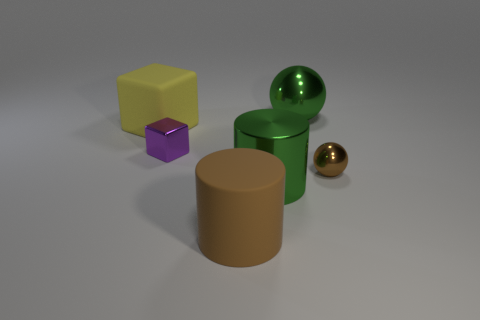Is there anything else that has the same shape as the brown matte object?
Your response must be concise. Yes. Are there more rubber things than small brown metal objects?
Your answer should be very brief. Yes. What number of other things are the same material as the green sphere?
Provide a short and direct response. 3. What is the shape of the big green metal object behind the green object in front of the small object that is to the right of the large brown cylinder?
Keep it short and to the point. Sphere. Are there fewer green metal spheres that are behind the purple object than big yellow rubber objects in front of the small metallic sphere?
Provide a short and direct response. No. Are there any matte cubes that have the same color as the small ball?
Your answer should be compact. No. Does the yellow object have the same material as the ball that is in front of the small metallic cube?
Your response must be concise. No. Is there a yellow matte object to the right of the metallic sphere that is behind the small purple object?
Your response must be concise. No. The thing that is both behind the small metal cube and to the right of the large green shiny cylinder is what color?
Your answer should be compact. Green. What size is the purple thing?
Provide a succinct answer. Small. 